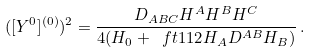Convert formula to latex. <formula><loc_0><loc_0><loc_500><loc_500>( [ Y ^ { 0 } ] ^ { ( 0 ) } ) ^ { 2 } = \frac { D _ { A B C } H ^ { A } H ^ { B } H ^ { C } } { 4 ( H _ { 0 } + \ f t { 1 } { 1 2 } H _ { A } D ^ { A B } H _ { B } ) } \, .</formula> 